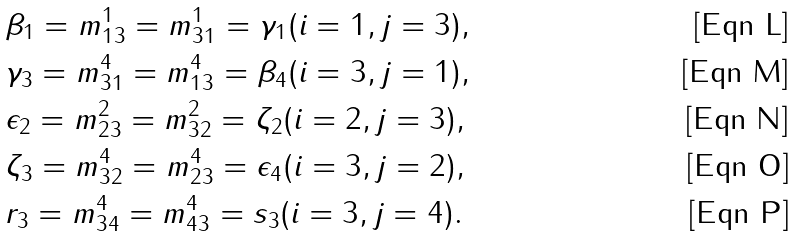<formula> <loc_0><loc_0><loc_500><loc_500>& \beta _ { 1 } = m _ { 1 3 } ^ { 1 } = m _ { 3 1 } ^ { 1 } = \gamma _ { 1 } ( i = 1 , j = 3 ) , \\ & \gamma _ { 3 } = m _ { 3 1 } ^ { 4 } = m _ { 1 3 } ^ { 4 } = \beta _ { 4 } ( i = 3 , j = 1 ) , \\ & \epsilon _ { 2 } = m _ { 2 3 } ^ { 2 } = m _ { 3 2 } ^ { 2 } = \zeta _ { 2 } ( i = 2 , j = 3 ) , \\ & \zeta _ { 3 } = m _ { 3 2 } ^ { 4 } = m _ { 2 3 } ^ { 4 } = \epsilon _ { 4 } ( i = 3 , j = 2 ) , \\ & r _ { 3 } = m _ { 3 4 } ^ { 4 } = m _ { 4 3 } ^ { 4 } = s _ { 3 } ( i = 3 , j = 4 ) .</formula> 